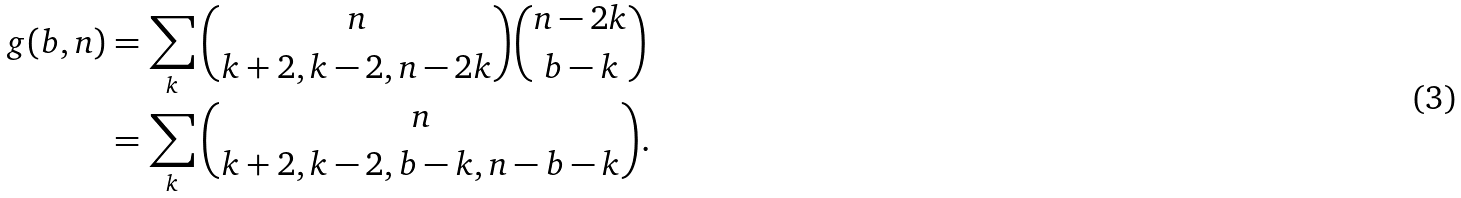Convert formula to latex. <formula><loc_0><loc_0><loc_500><loc_500>g ( b , n ) & = \sum _ { k } { n \choose k + 2 , k - 2 , n - 2 k } { n - 2 k \choose b - k } \\ & = \sum _ { k } { n \choose k + 2 , k - 2 , b - k , n - b - k } .</formula> 